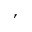<formula> <loc_0><loc_0><loc_500><loc_500>,</formula> 